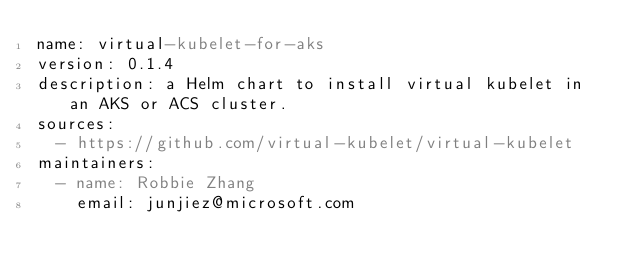Convert code to text. <code><loc_0><loc_0><loc_500><loc_500><_YAML_>name: virtual-kubelet-for-aks
version: 0.1.4
description: a Helm chart to install virtual kubelet in an AKS or ACS cluster.
sources:
  - https://github.com/virtual-kubelet/virtual-kubelet
maintainers:
  - name: Robbie Zhang
    email: junjiez@microsoft.com
</code> 